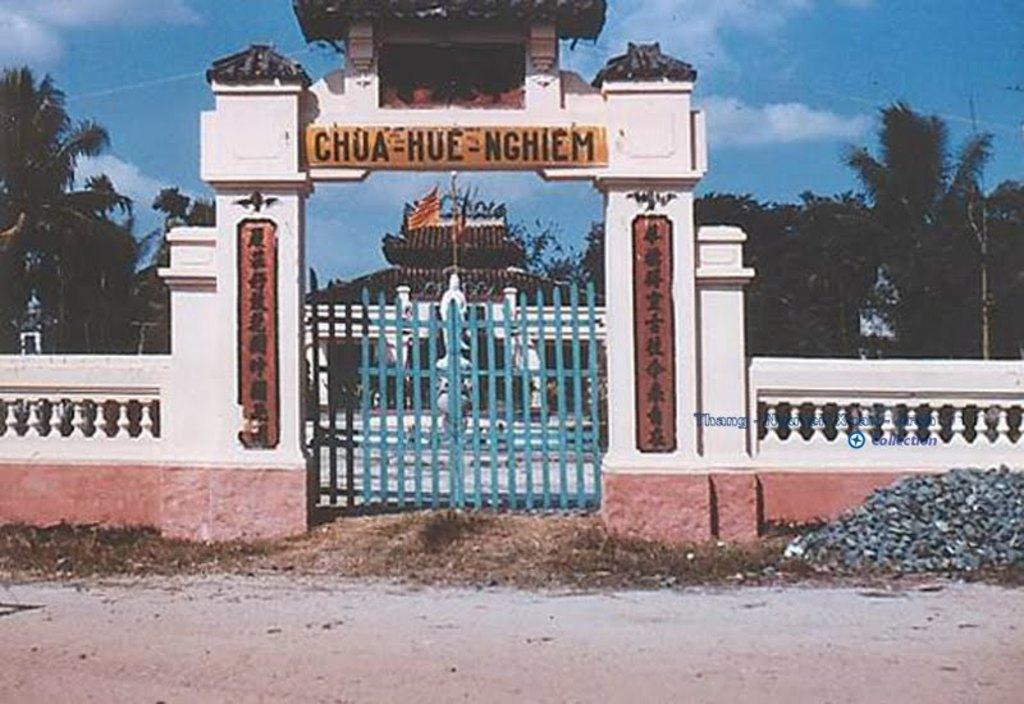What type of structures can be seen in the image? There are gates and a fence in the image. What is written in the image? There is something written in the image. What can be seen in the background of the image? There is a building, trees, and the sky visible in the background of the image. How does the goose contribute to the growth of the trees in the image? There is no goose present in the image, so it cannot contribute to the growth of the trees. 